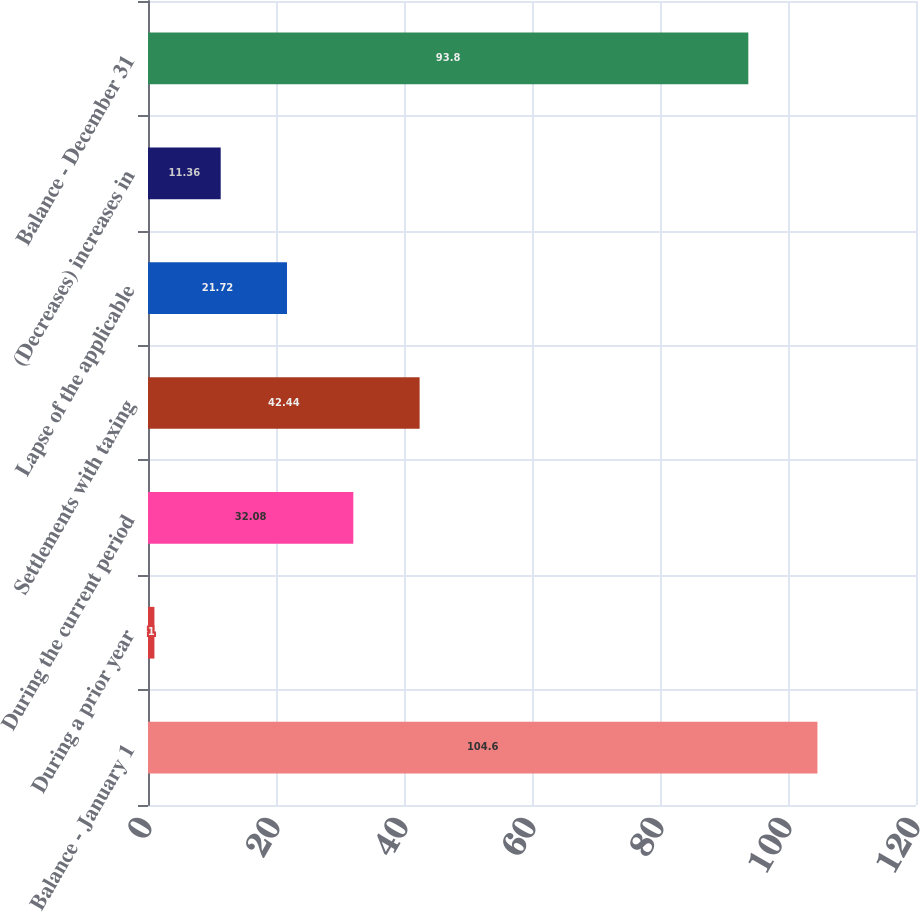<chart> <loc_0><loc_0><loc_500><loc_500><bar_chart><fcel>Balance - January 1<fcel>During a prior year<fcel>During the current period<fcel>Settlements with taxing<fcel>Lapse of the applicable<fcel>(Decreases) increases in<fcel>Balance - December 31<nl><fcel>104.6<fcel>1<fcel>32.08<fcel>42.44<fcel>21.72<fcel>11.36<fcel>93.8<nl></chart> 